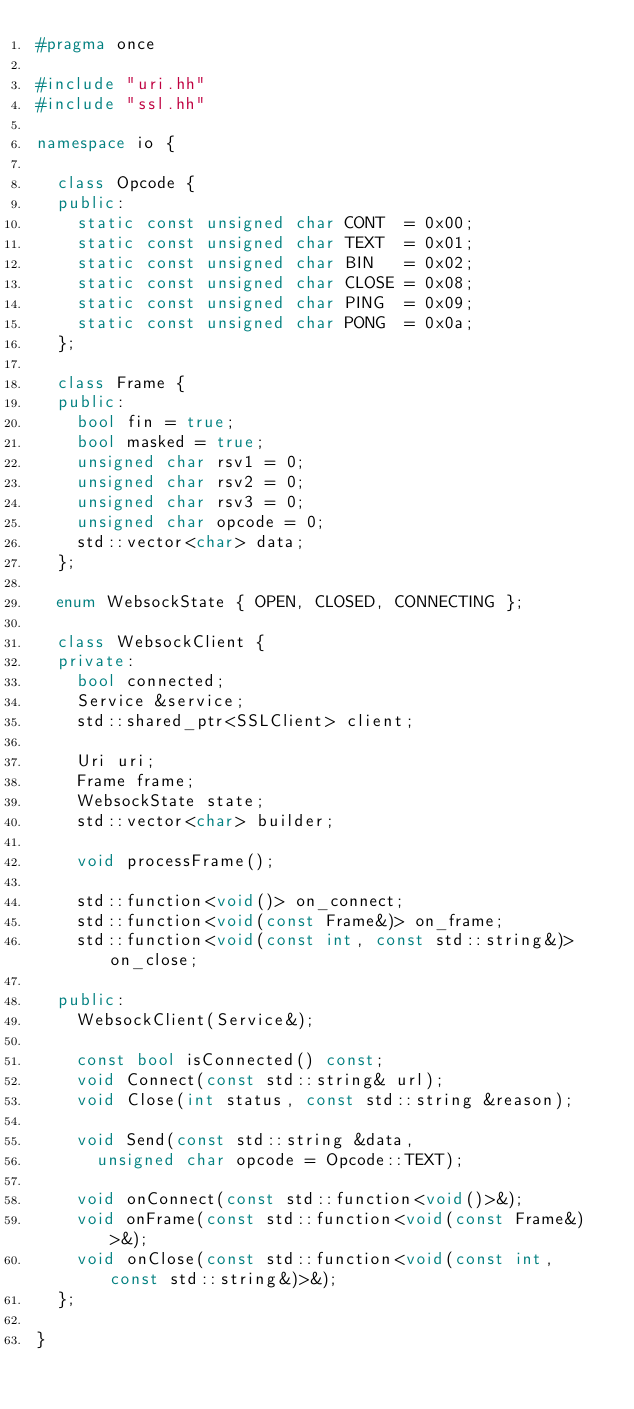<code> <loc_0><loc_0><loc_500><loc_500><_C++_>#pragma once

#include "uri.hh"
#include "ssl.hh"

namespace io {

  class Opcode {
  public:
    static const unsigned char CONT  = 0x00;
    static const unsigned char TEXT  = 0x01;
    static const unsigned char BIN   = 0x02;
    static const unsigned char CLOSE = 0x08;
    static const unsigned char PING  = 0x09;
    static const unsigned char PONG  = 0x0a;
  };

  class Frame {
  public:
    bool fin = true;
    bool masked = true;
    unsigned char rsv1 = 0;
    unsigned char rsv2 = 0;
    unsigned char rsv3 = 0;
    unsigned char opcode = 0;
    std::vector<char> data;
  };

  enum WebsockState { OPEN, CLOSED, CONNECTING };

  class WebsockClient {
  private:
    bool connected;
    Service &service;
    std::shared_ptr<SSLClient> client;

    Uri uri;
    Frame frame;
    WebsockState state;
    std::vector<char> builder;

    void processFrame();

    std::function<void()> on_connect;
    std::function<void(const Frame&)> on_frame;
    std::function<void(const int, const std::string&)> on_close;

  public:
    WebsockClient(Service&);

    const bool isConnected() const;
    void Connect(const std::string& url);
    void Close(int status, const std::string &reason);

    void Send(const std::string &data,
      unsigned char opcode = Opcode::TEXT);

    void onConnect(const std::function<void()>&);
    void onFrame(const std::function<void(const Frame&)>&);
    void onClose(const std::function<void(const int, const std::string&)>&);
  };

}</code> 